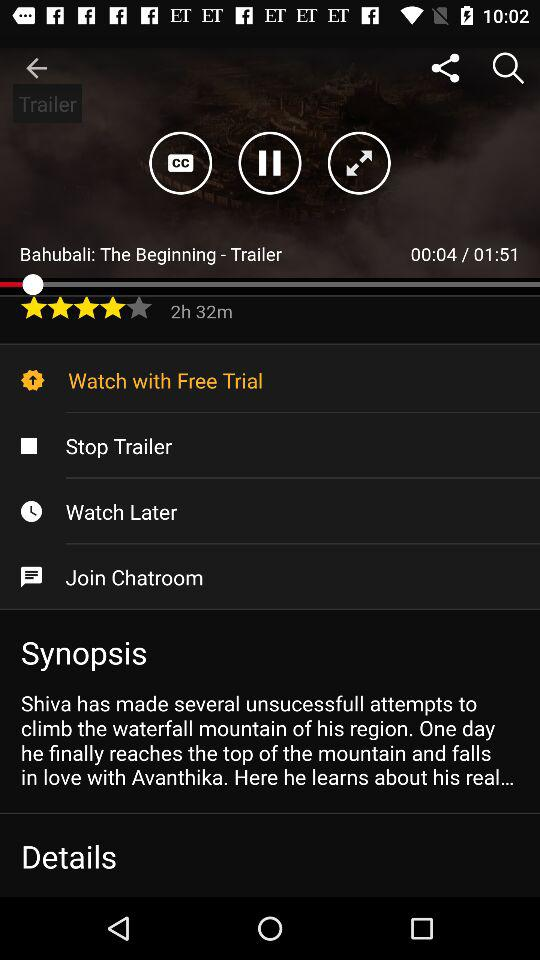How long is the trailer? The trailer is 1 minute and 52 seconds long. 